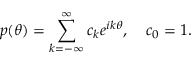<formula> <loc_0><loc_0><loc_500><loc_500>p ( \theta ) = \sum _ { k = - \infty } ^ { \infty } c _ { k } e ^ { i k \theta } , \quad c _ { 0 } = 1 .</formula> 